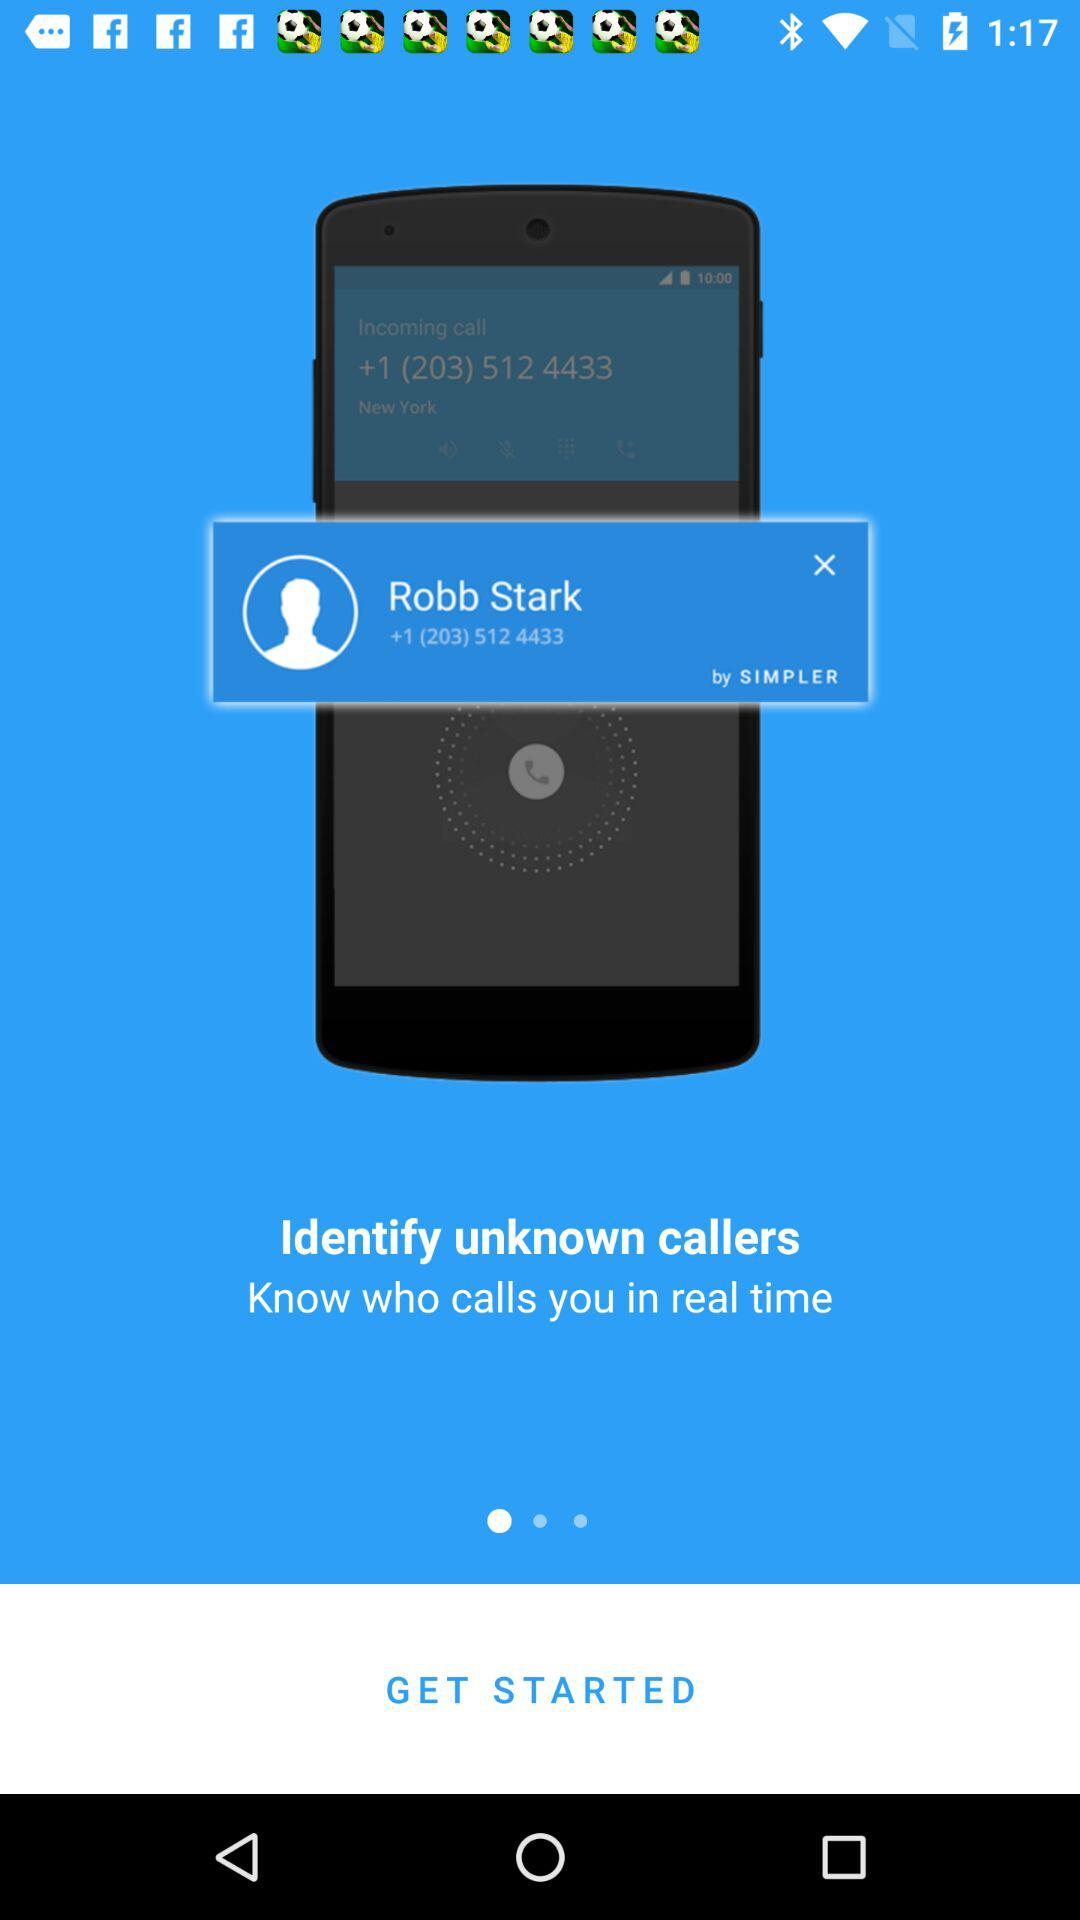What is the name of the user? The name of the user is Robb Stark. 